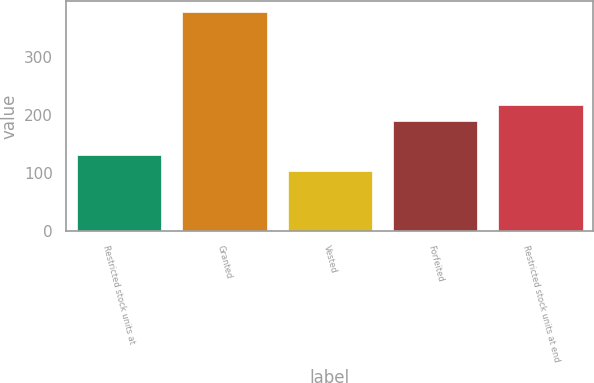<chart> <loc_0><loc_0><loc_500><loc_500><bar_chart><fcel>Restricted stock units at<fcel>Granted<fcel>Vested<fcel>Forfeited<fcel>Restricted stock units at end<nl><fcel>130.88<fcel>376.95<fcel>103.54<fcel>189.05<fcel>216.39<nl></chart> 